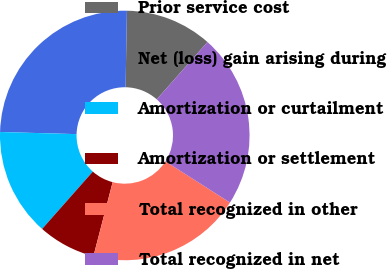Convert chart. <chart><loc_0><loc_0><loc_500><loc_500><pie_chart><fcel>Prior service cost<fcel>Net (loss) gain arising during<fcel>Amortization or curtailment<fcel>Amortization or settlement<fcel>Total recognized in other<fcel>Total recognized in net<nl><fcel>11.26%<fcel>24.83%<fcel>13.92%<fcel>7.48%<fcel>20.01%<fcel>22.5%<nl></chart> 